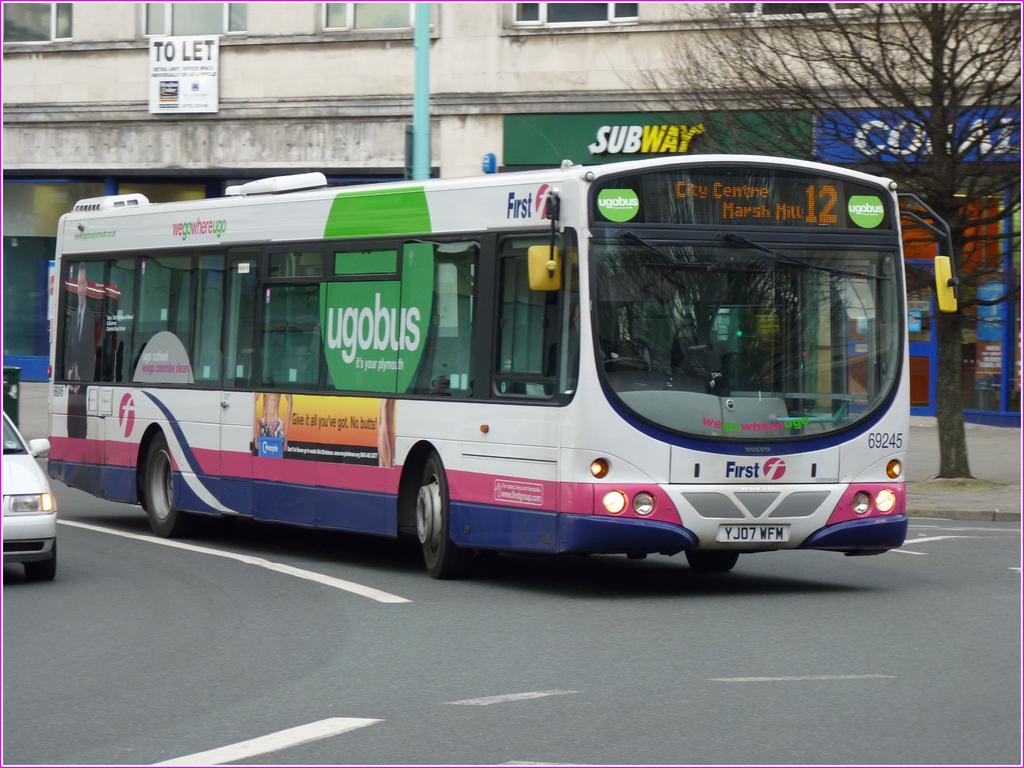Where does this bus run?
Give a very brief answer. City center. Where is this bus from?
Provide a short and direct response. Ugobus. 